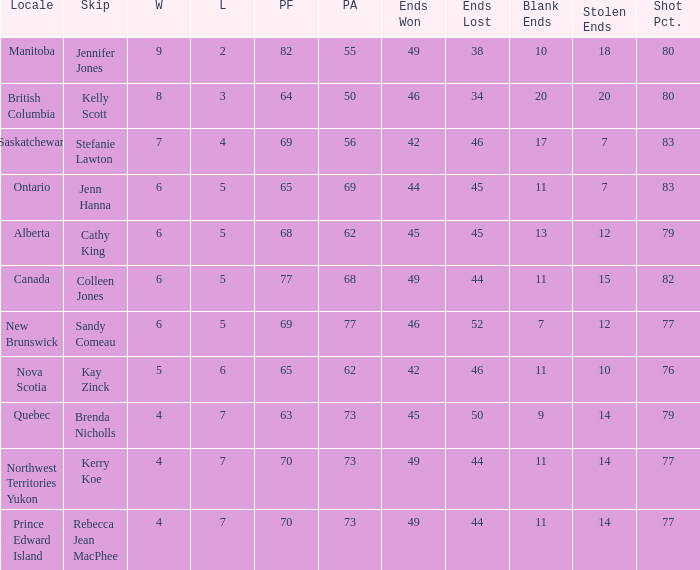What is the total number of ends won when the locale is Northwest Territories Yukon? 1.0. 